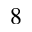<formula> <loc_0><loc_0><loc_500><loc_500>8</formula> 